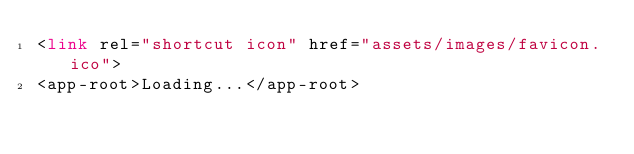<code> <loc_0><loc_0><loc_500><loc_500><_HTML_><link rel="shortcut icon" href="assets/images/favicon.ico">
<app-root>Loading...</app-root>
</code> 